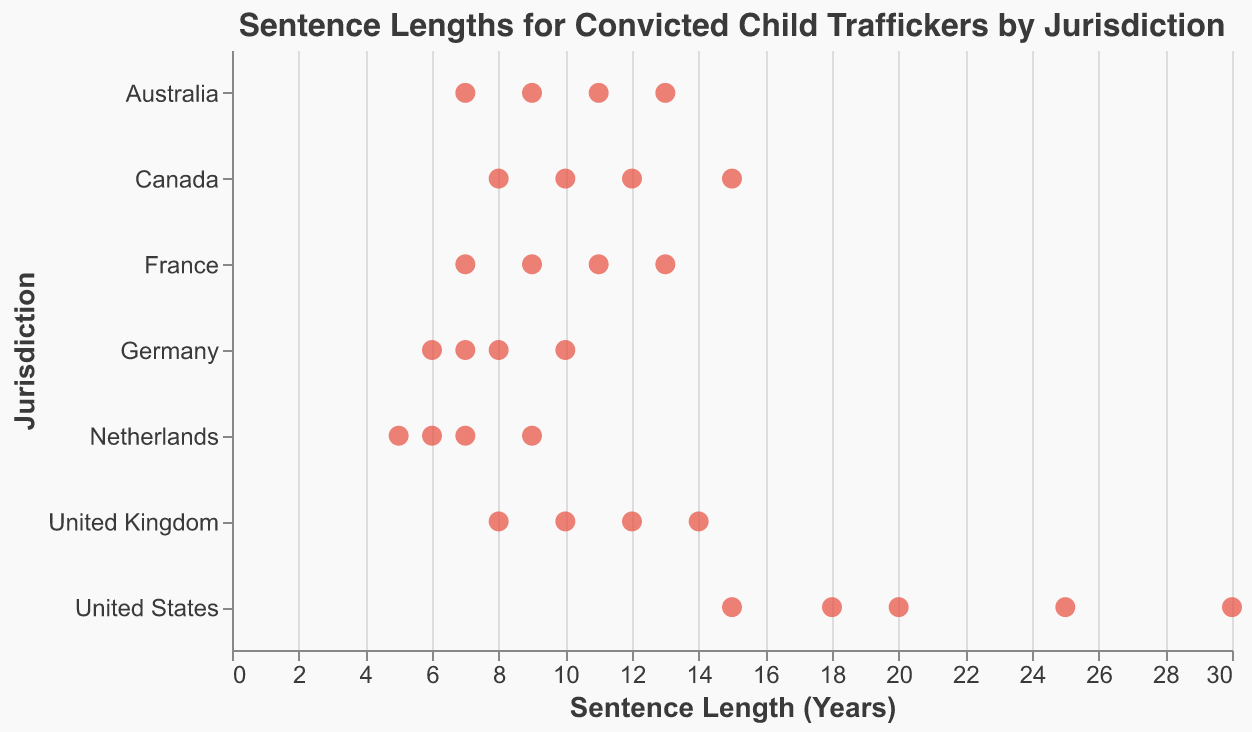Which jurisdiction has the longest sentence length? The plot indicates jurisdictions and the corresponding sentence lengths. By examining the plot, the United States has the highest sentence length of 30 years.
Answer: United States What is the range of sentence lengths in Germany? To determine the range, find the difference between the maximum and minimum sentence lengths in Germany. The maximum is 10 years, and the minimum is 6 years, so the range is 10 - 6 = 4 years.
Answer: 4 years Which jurisdiction has the lowest average sentence length? Calculate the average sentence length for each jurisdiction and compare. The Netherlands has sentence lengths of 5, 7, 9, and 6; their average is (5 + 7 + 9 + 6) / 4 = 6.75 years, which is the lowest among all jurisdictions.
Answer: Netherlands How does the sentence length distribution in the United Kingdom compare to that in Australia? Compare the range and median sentence lengths. The UK has lengths of 8 to 14 years, and Australia has lengths of 7 to 13 years. Both have a median of 10 years, but the UK's range is slightly broader.
Answer: Similar median, but the UK's range is slightly broader What is the median sentence length in France? Sort the French sentence lengths: 7, 9, 11, 13. The median is the average of the two middle numbers: (9 + 11) / 2 = 10 years.
Answer: 10 years In which jurisdictions do we see sentence lengths of 13 years? Identify which jurisdictions have 13-year sentence lengths. According to the plot, France and Australia have sentence lengths of 13 years.
Answer: France, Australia Compare the sentence lengths in Canada and Germany. Which has more variability? Assess the range and spread of marks for both countries. Canada ranges from 8 to 15 years, Germany from 6 to 10 years. Canada's range (7 years) is greater than Germany's (4 years).
Answer: Canada What is the average sentence length in the United States? Add up all sentence lengths in the US (15, 20, 25, 18, 30) and divide by the number of points: (15 + 20 + 25 + 18 + 30) / 5 = 21.6 years.
Answer: 21.6 years If you were to group jurisdictions into those with an average sentence length above 10 years and those with 10 years or less, which countries fall into each group? Calculate the average for each jurisdiction and compare to 10 years. Above 10: United States (21.6), Canada (11.25), UK (11), France (10). 10 or less: Australia (10), Germany (7.75), Netherlands (6.75).
Answer: Above 10: United States, Canada, UK, France; 10 or less: Australia, Germany, Netherlands 